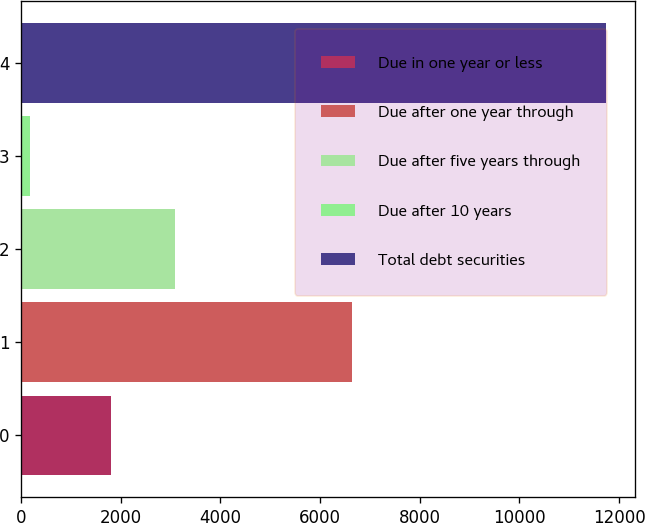<chart> <loc_0><loc_0><loc_500><loc_500><bar_chart><fcel>Due in one year or less<fcel>Due after one year through<fcel>Due after five years through<fcel>Due after 10 years<fcel>Total debt securities<nl><fcel>1812<fcel>6646<fcel>3097<fcel>182<fcel>11737<nl></chart> 